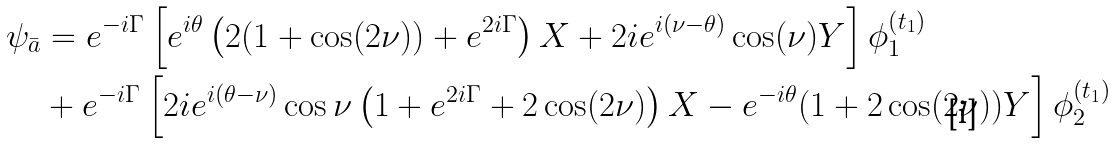<formula> <loc_0><loc_0><loc_500><loc_500>\psi _ { \bar { a } } & = e ^ { - i \Gamma } \left [ e ^ { i \theta } \left ( 2 ( 1 + \cos ( 2 \nu ) ) + e ^ { 2 i \Gamma } \right ) X + 2 i e ^ { i ( \nu - \theta ) } \cos ( \nu ) Y \right ] \phi _ { 1 } ^ { \left ( t _ { 1 } \right ) } \\ & + e ^ { - i \Gamma } \left [ 2 i e ^ { i ( \theta - \nu ) } \cos \nu \left ( 1 + e ^ { 2 i \Gamma } + 2 \cos ( 2 \nu ) \right ) X - e ^ { - i \theta } ( 1 + 2 \cos ( 2 \nu ) ) Y \right ] \phi _ { 2 } ^ { \left ( t _ { 1 } \right ) } \\</formula> 